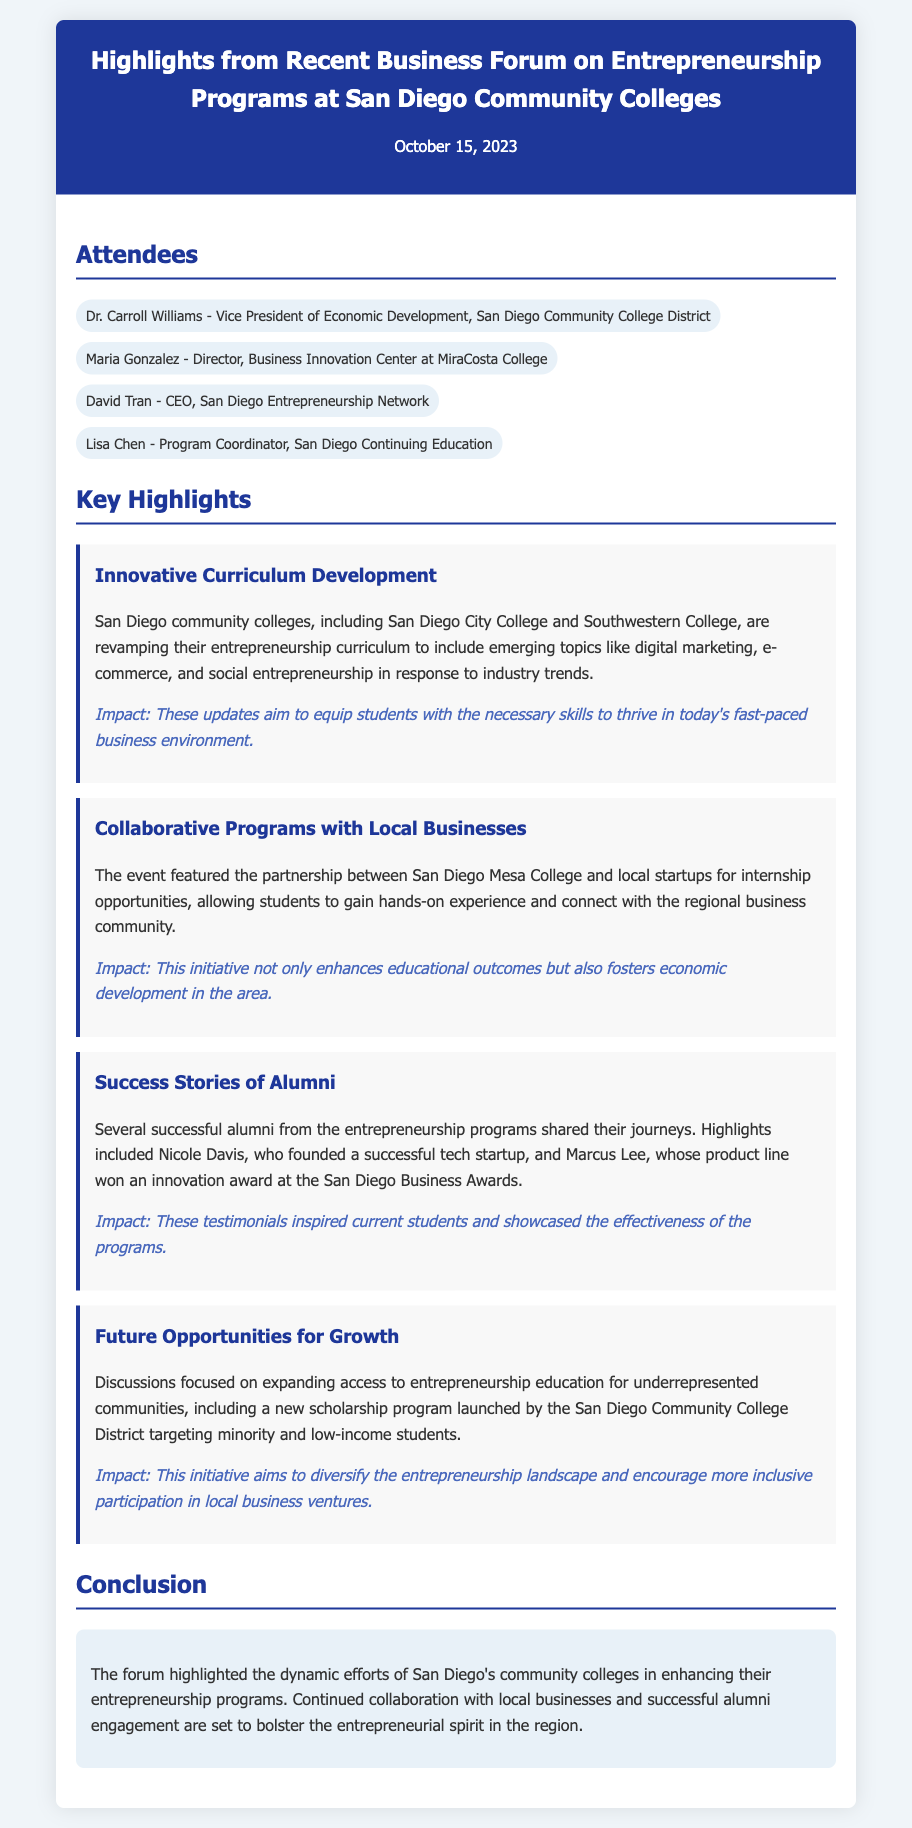What is the date of the memo? The date of the memo is stated at the top of the document.
Answer: October 15, 2023 Who is the Vice President of Economic Development for San Diego Community College District? The document lists the attendees, including the Vice President.
Answer: Dr. Carroll Williams Which college is collaborating with local startups for internship opportunities? The document mentions a specific college involved in partnerships with local businesses.
Answer: San Diego Mesa College What is one of the emerging topics included in the revamped entrepreneurship curriculum? The key highlights section describes topics in the new curriculum.
Answer: Digital marketing Who founded a successful tech startup mentioned in the success stories? The document includes specific alumni who shared their success stories.
Answer: Nicole Davis What is the target group of the new scholarship program? The section on future opportunities indicates who the scholarship program aims to assist.
Answer: Minority and low-income students What is the goal of the initiative to expand access to entrepreneurship education? The document explains the purpose of the initiative discussed at the forum.
Answer: Diversify the entrepreneurship landscape What impact do the updates to the curriculum aim to have? The document explains the intended outcomes of the curriculum development.
Answer: Equip students with necessary skills How many key highlights are presented in the memo? The number of distinct sections under key highlights can be counted.
Answer: Four 